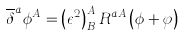<formula> <loc_0><loc_0><loc_500><loc_500>\overline { \delta } ^ { a } \phi ^ { A } = \left ( \epsilon ^ { 2 } \right ) ^ { A } _ { B } R ^ { a A } \left ( \phi + \varphi \right )</formula> 